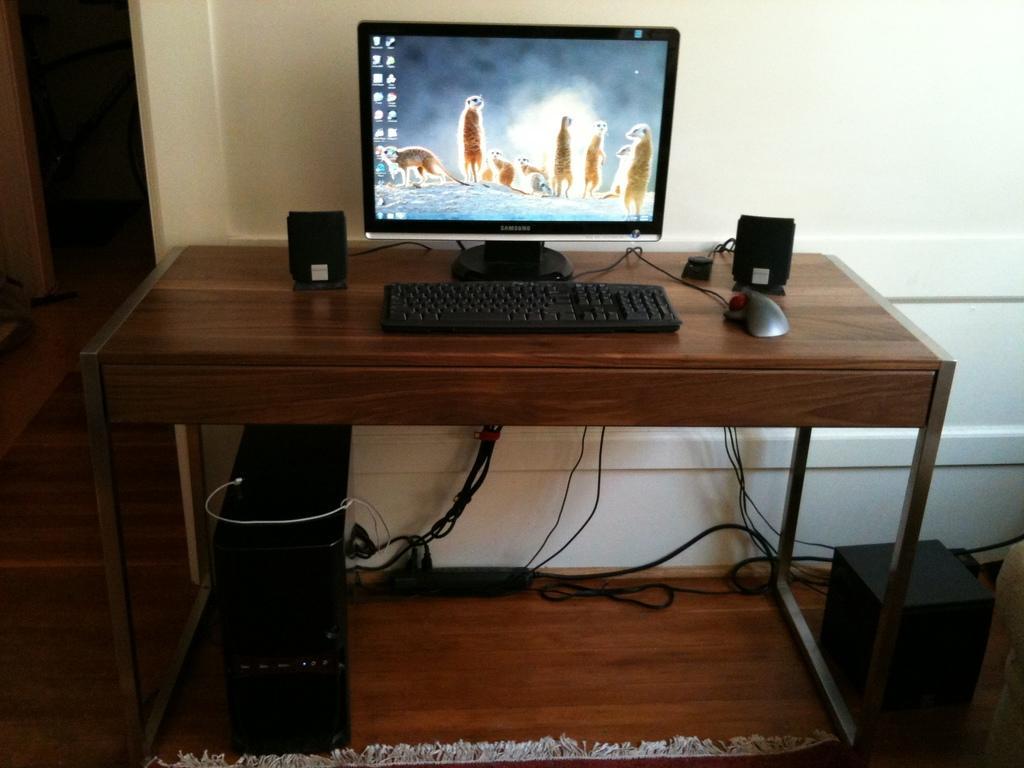Describe this image in one or two sentences. in this image i can see a table on which there is a computer,keyboard, two speakers at the right and left and a mouse. below that there is CPU and wires. behind that there is cream color wall. 